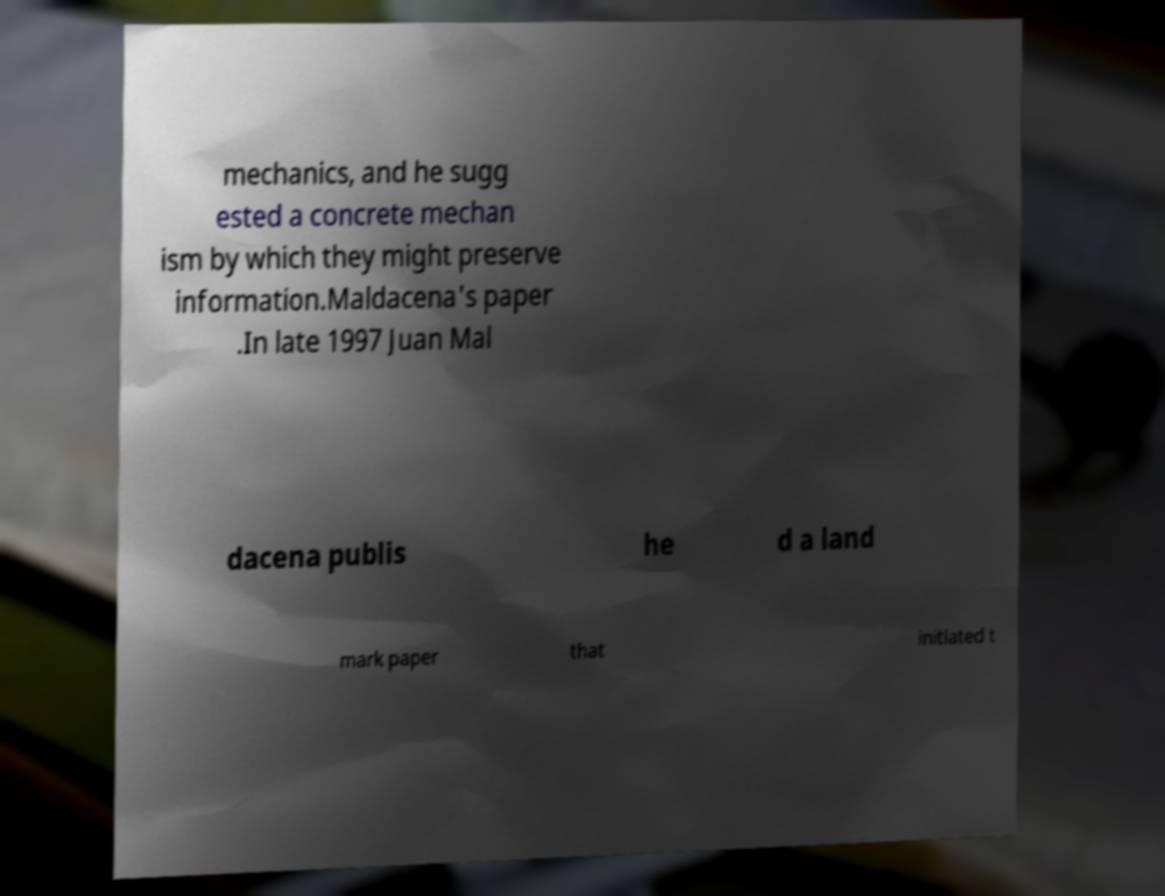There's text embedded in this image that I need extracted. Can you transcribe it verbatim? mechanics, and he sugg ested a concrete mechan ism by which they might preserve information.Maldacena's paper .In late 1997 Juan Mal dacena publis he d a land mark paper that initiated t 